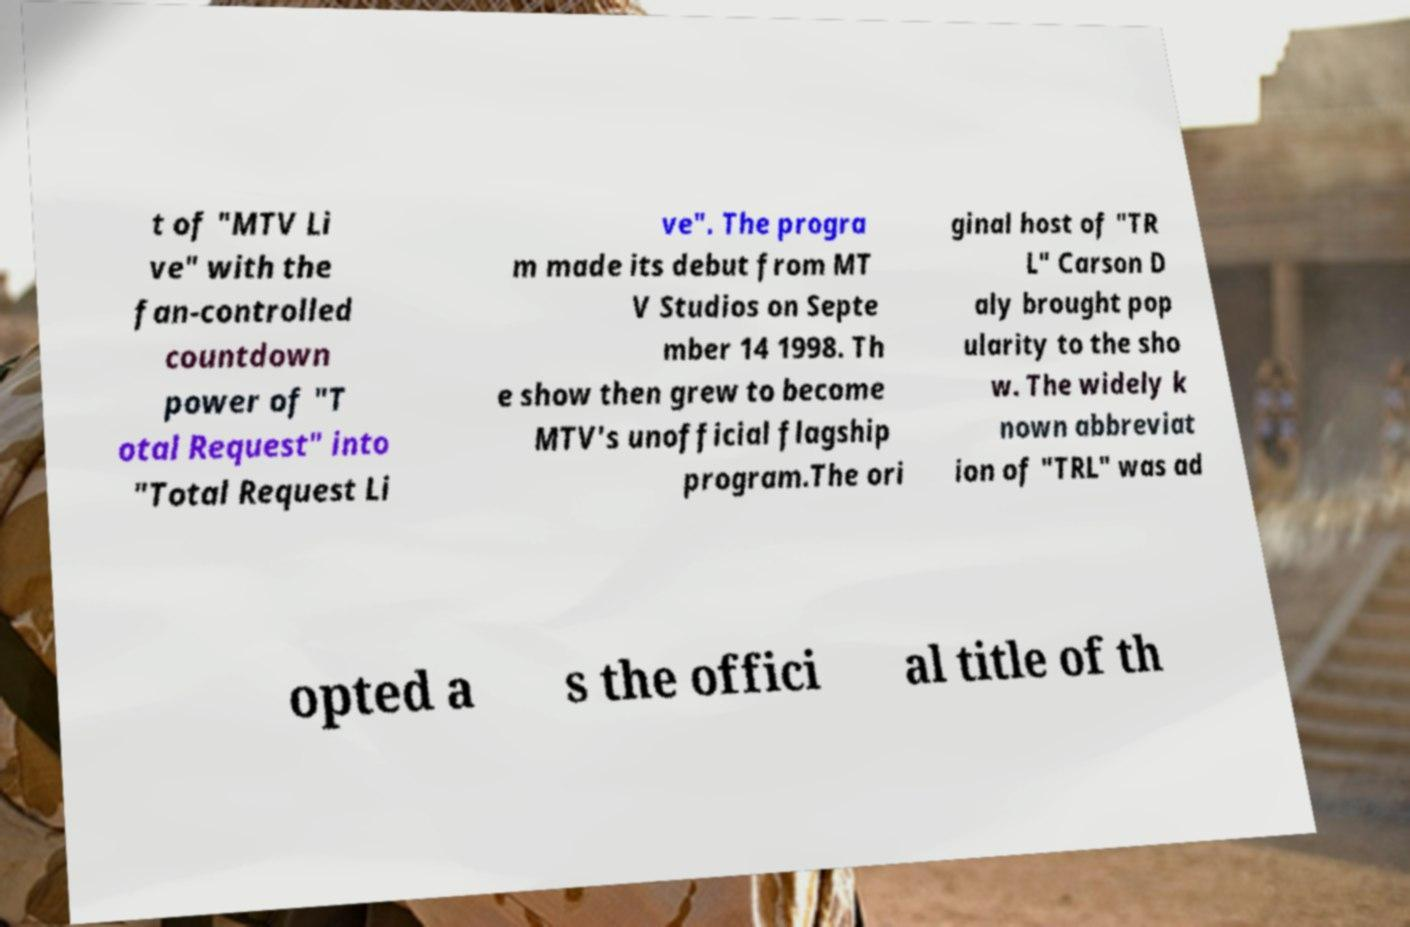Can you read and provide the text displayed in the image?This photo seems to have some interesting text. Can you extract and type it out for me? t of "MTV Li ve" with the fan-controlled countdown power of "T otal Request" into "Total Request Li ve". The progra m made its debut from MT V Studios on Septe mber 14 1998. Th e show then grew to become MTV's unofficial flagship program.The ori ginal host of "TR L" Carson D aly brought pop ularity to the sho w. The widely k nown abbreviat ion of "TRL" was ad opted a s the offici al title of th 